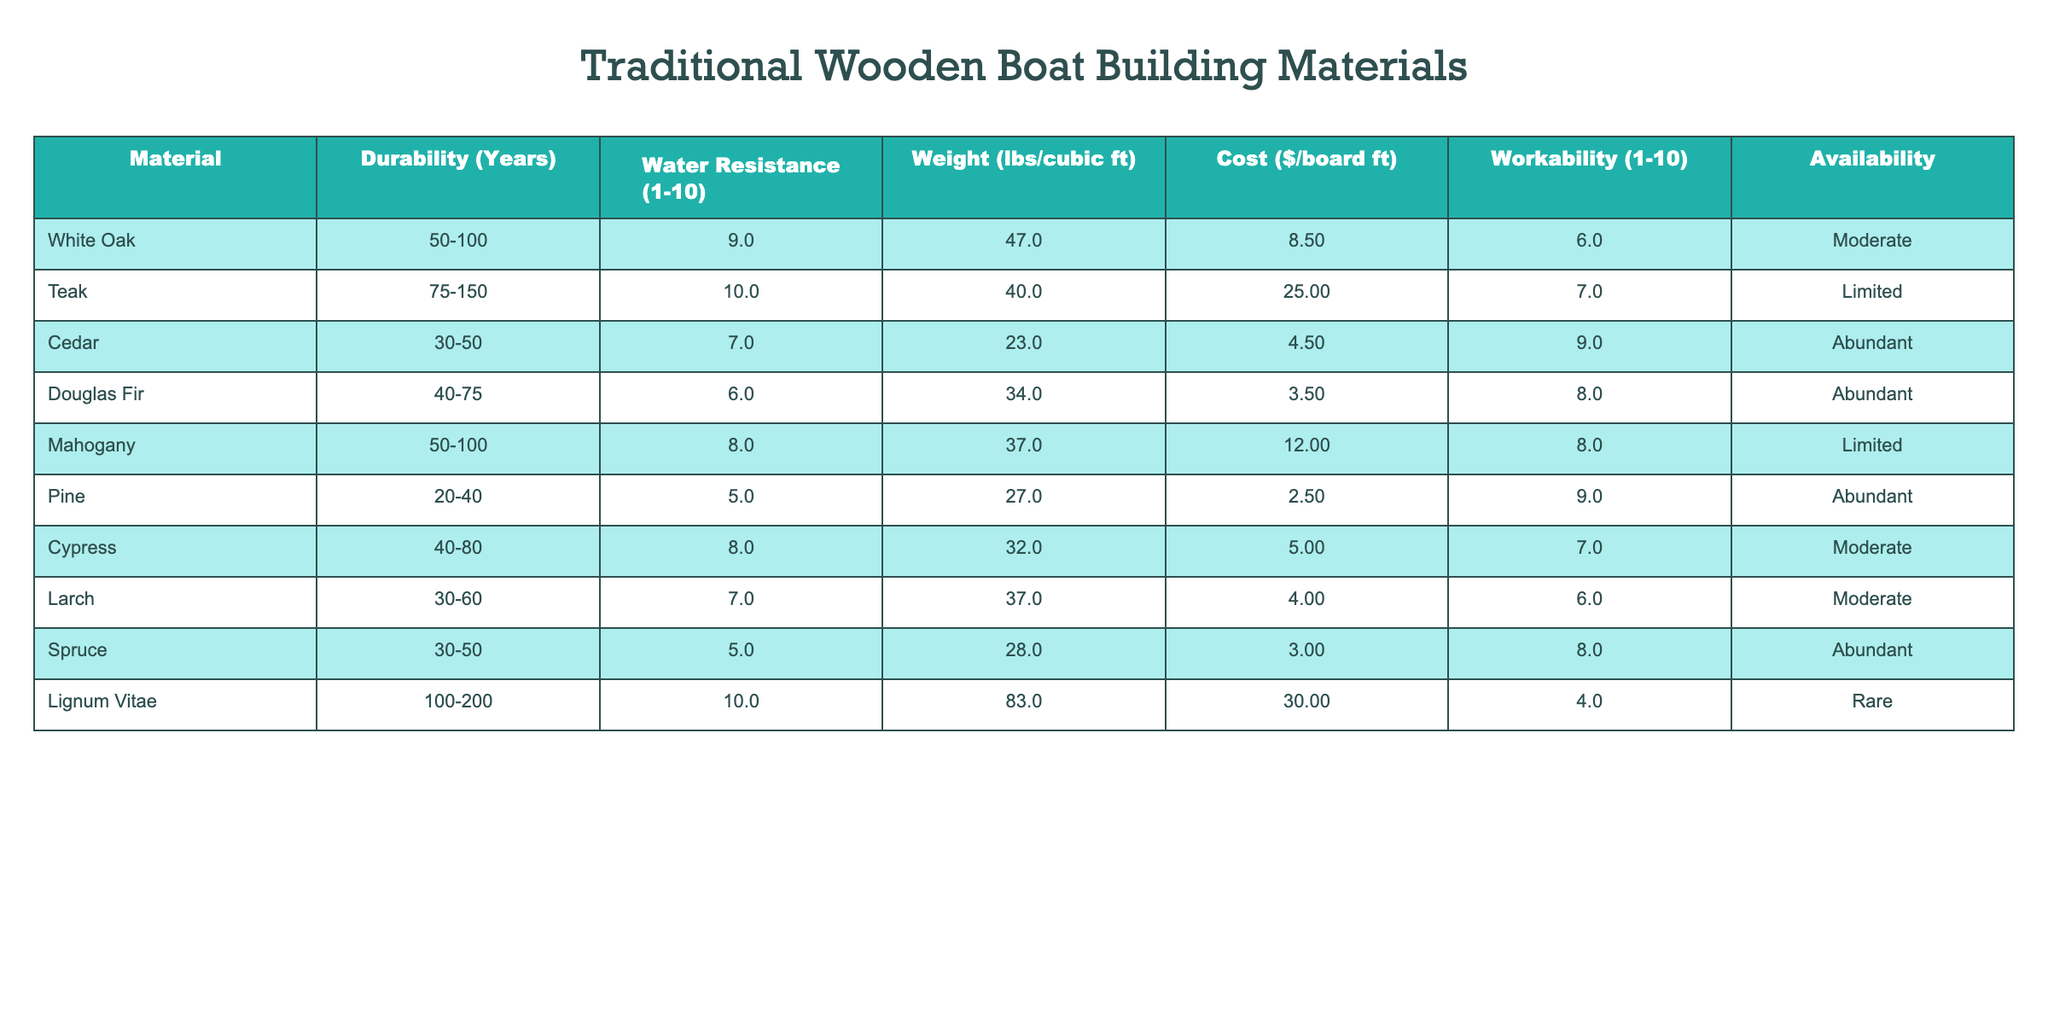What is the durability of Teak? The table shows that the durability of Teak is between 75 to 150 years.
Answer: 75-150 years Which material has the highest water resistance rating? According to the table, both Teak and Lignum Vitae have the highest water resistance rating of 10.
Answer: Teak and Lignum Vitae What is the weight of Cedar in lbs per cubic ft? The table lists the weight of Cedar as 23 lbs per cubic ft.
Answer: 23 lbs/cubic ft How many materials have a durability of 50 years or more? The materials with a durability of 50 years or more are White Oak, Teak, Mahogany, and Lignum Vitae, totaling 4 materials.
Answer: 4 materials Is Pine more water-resistant than Spruce? The table indicates that Pine has a water resistance rating of 5, while Spruce has a rating of 5 as well, so they are equal.
Answer: No What is the average weight of materials listed in the table? Add all the weights: (47 + 40 + 23 + 34 + 37 + 27 + 32 + 37 + 28 + 83) = 413 lbs. There are 10 materials, so the average weight is 413/10 = 41.3 lbs/cubic ft.
Answer: 41.3 lbs/cubic ft Which material has the lowest cost per board foot? Pine has the lowest cost at $2.50 per board foot according to the table.
Answer: $2.50 If you combine the water resistance ratings of Douglas Fir and Cypress, what is the total? Douglas Fir has a rating of 6 and Cypress has a rating of 8. Adding them together gives 6 + 8 = 14.
Answer: 14 Which material would you recommend for a project that requires good workability and is abundant? Cedar has the highest workability rating of 9 and is listed as abundant, making it a good choice for the project.
Answer: Cedar Is it true that all materials are readily available? The table shows that only Cedar, Douglas Fir, Pine, and Spruce are abundant, while others are limited or rare, so not all materials are readily available.
Answer: No 